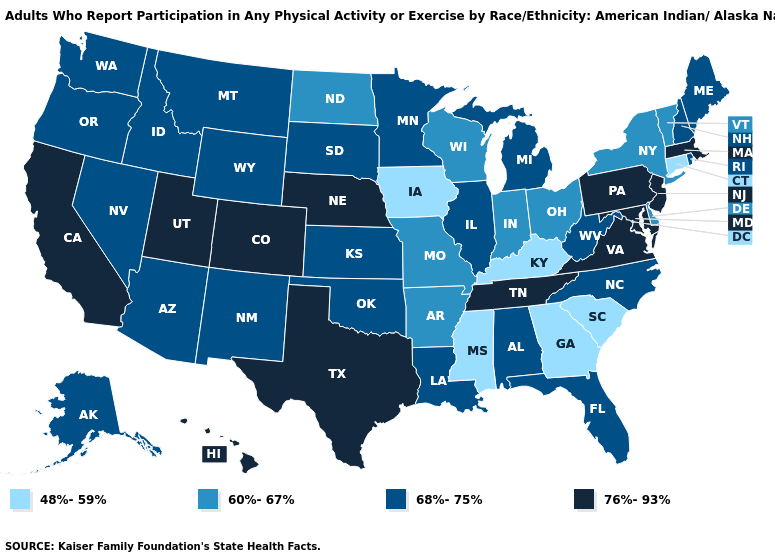What is the value of Michigan?
Quick response, please. 68%-75%. Name the states that have a value in the range 48%-59%?
Answer briefly. Connecticut, Georgia, Iowa, Kentucky, Mississippi, South Carolina. Does South Carolina have the lowest value in the South?
Short answer required. Yes. Among the states that border Wisconsin , which have the lowest value?
Keep it brief. Iowa. Which states have the lowest value in the West?
Keep it brief. Alaska, Arizona, Idaho, Montana, Nevada, New Mexico, Oregon, Washington, Wyoming. Does Ohio have the same value as Nebraska?
Keep it brief. No. Does Nebraska have a higher value than Illinois?
Give a very brief answer. Yes. What is the highest value in the West ?
Give a very brief answer. 76%-93%. Among the states that border Illinois , which have the lowest value?
Write a very short answer. Iowa, Kentucky. Does Idaho have the lowest value in the USA?
Give a very brief answer. No. What is the value of Montana?
Answer briefly. 68%-75%. Does Kansas have the highest value in the USA?
Concise answer only. No. Does South Carolina have the lowest value in the USA?
Quick response, please. Yes. What is the value of Colorado?
Keep it brief. 76%-93%. What is the value of Mississippi?
Give a very brief answer. 48%-59%. 